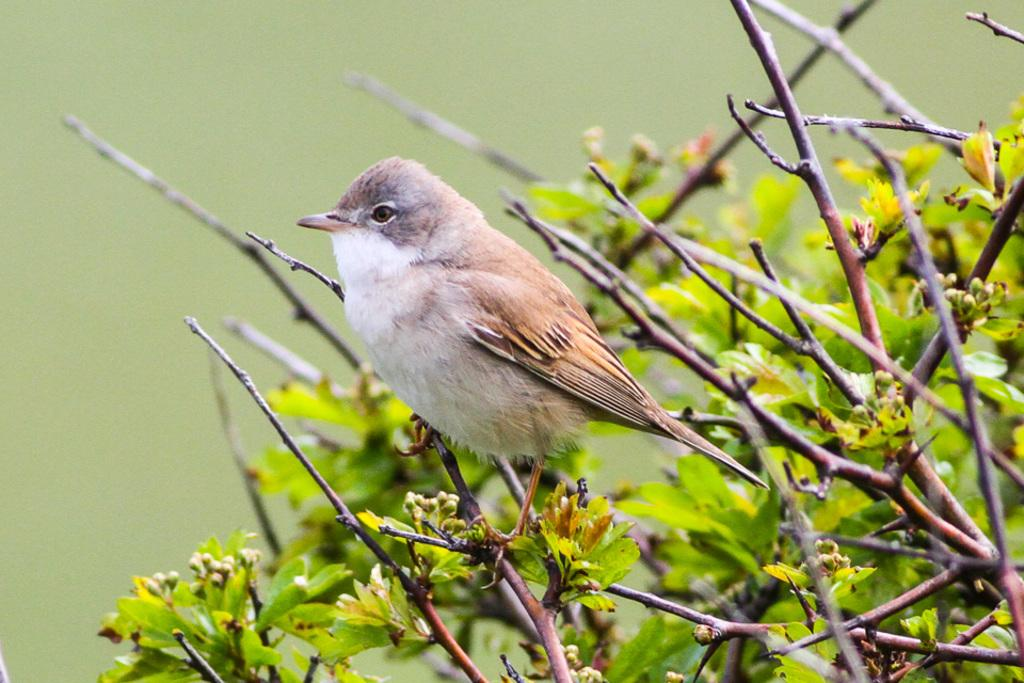What type of animal is in the image? There is a bird in the image. Where is the bird located? The bird is on the land. What colors can be seen on the bird? The bird has white and brown colors. What else can be seen in the image besides the bird? There is a plant in the image. How would you describe the background of the image? The background of the image is blurry. What type of card game is being played in the image? There is no card game present in the image; it features a bird on the land with a blurry background. 